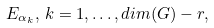<formula> <loc_0><loc_0><loc_500><loc_500>E _ { \alpha _ { k } } , \, k = 1 , \dots , d i m ( G ) - r ,</formula> 